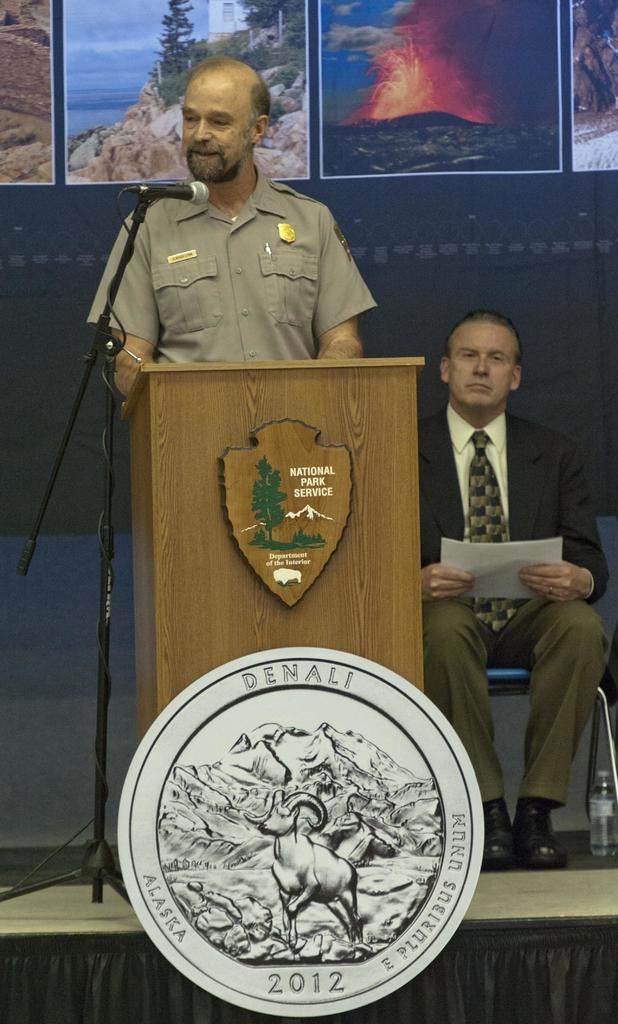<image>
Describe the image concisely. The speaker here is from the National Park Service 